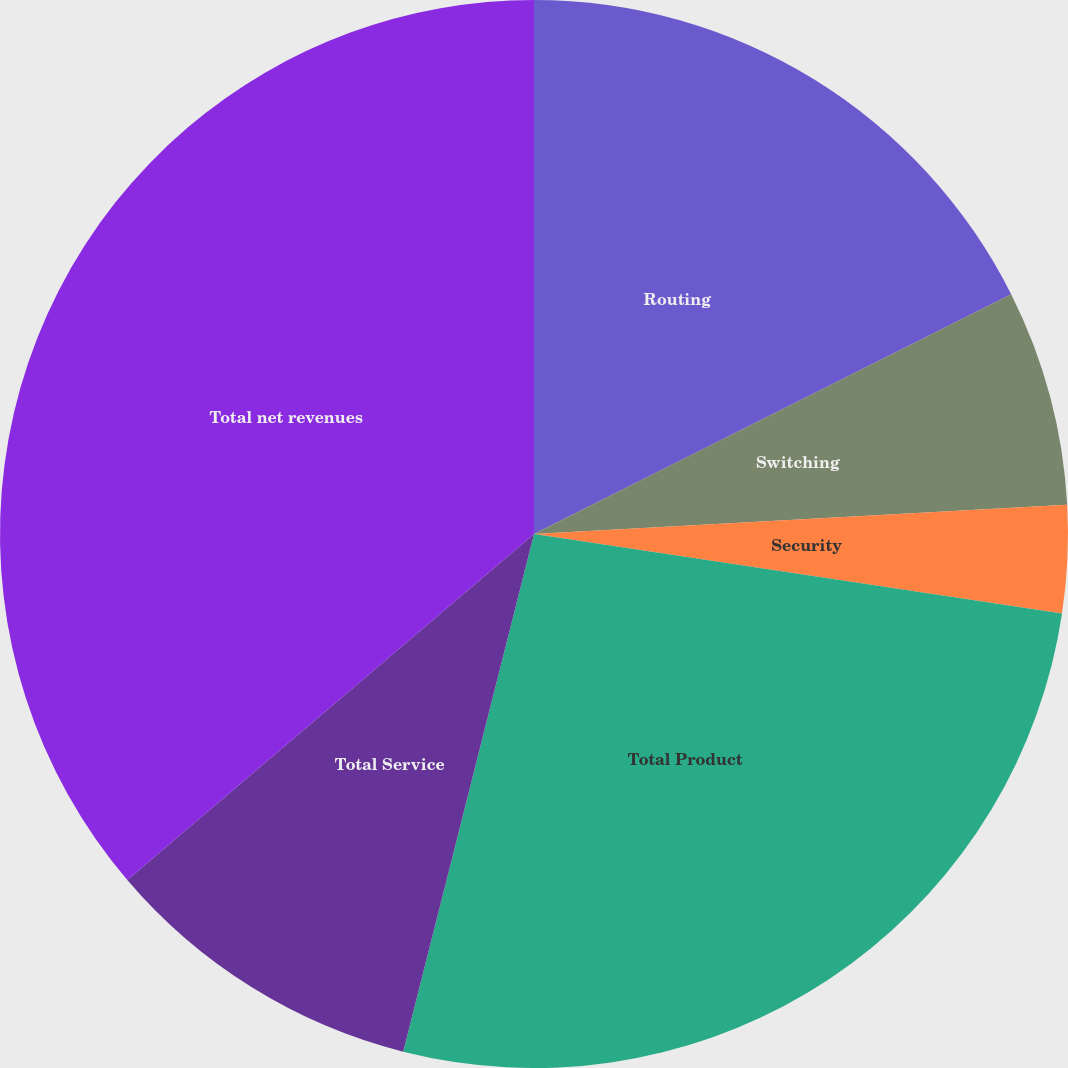<chart> <loc_0><loc_0><loc_500><loc_500><pie_chart><fcel>Routing<fcel>Switching<fcel>Security<fcel>Total Product<fcel>Total Service<fcel>Total net revenues<nl><fcel>17.59%<fcel>6.54%<fcel>3.25%<fcel>26.56%<fcel>9.84%<fcel>36.22%<nl></chart> 